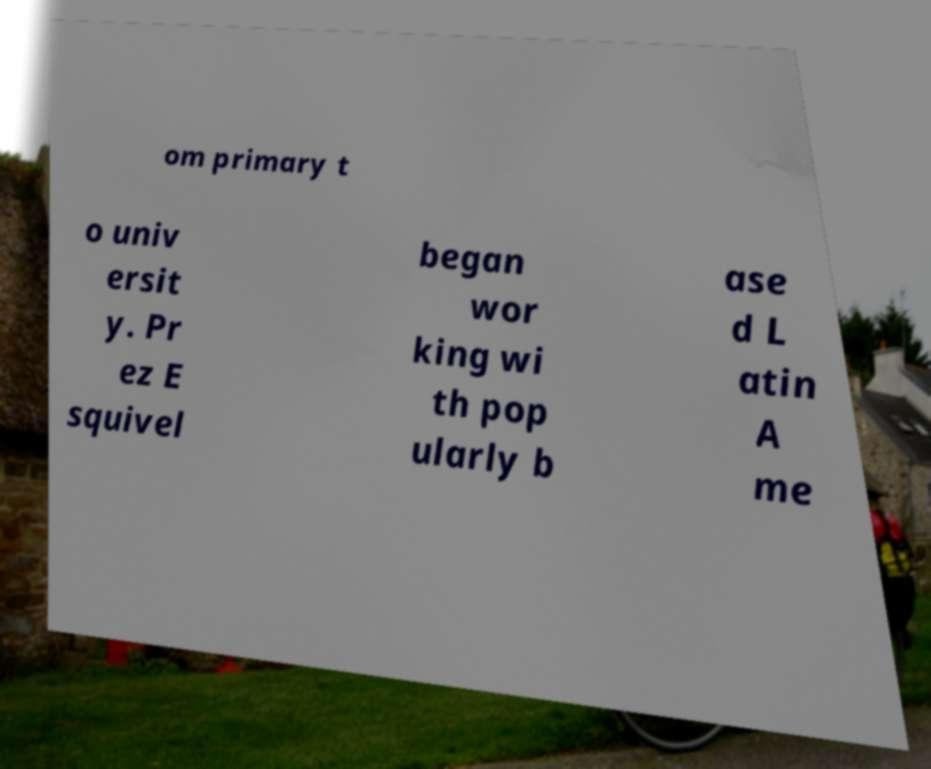I need the written content from this picture converted into text. Can you do that? om primary t o univ ersit y. Pr ez E squivel began wor king wi th pop ularly b ase d L atin A me 